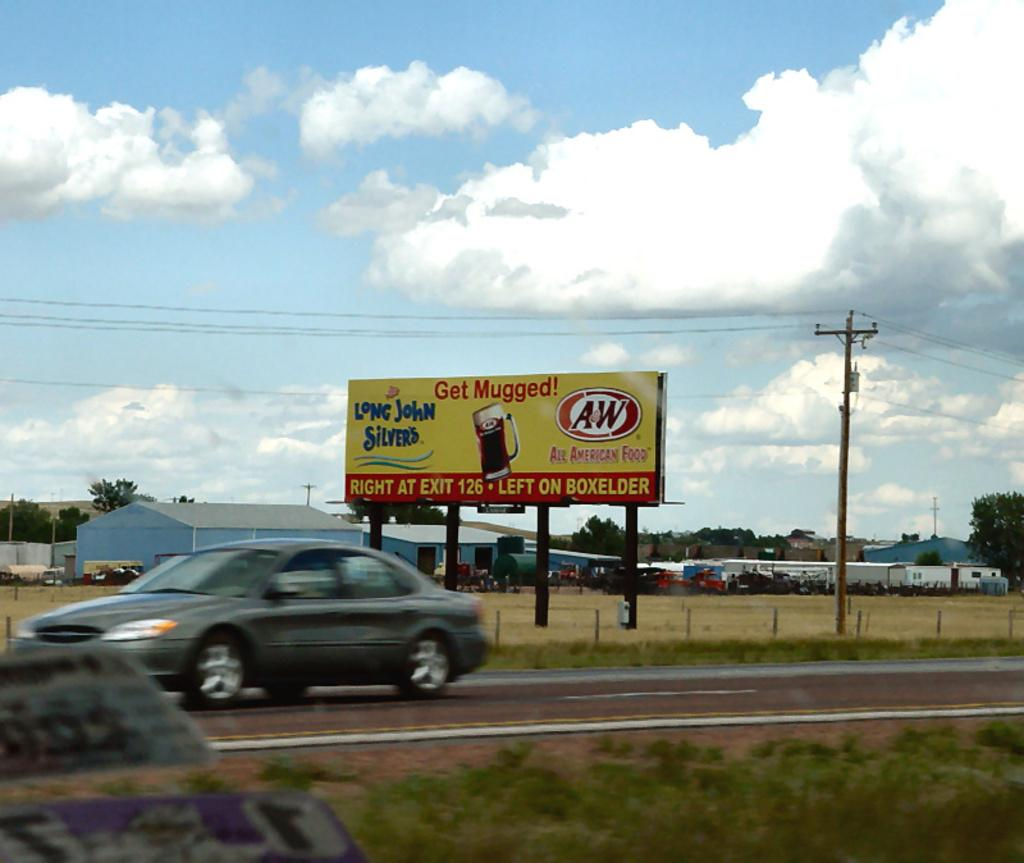<image>
Provide a brief description of the given image. A road sign the says "Get Mugged" for long john silver 